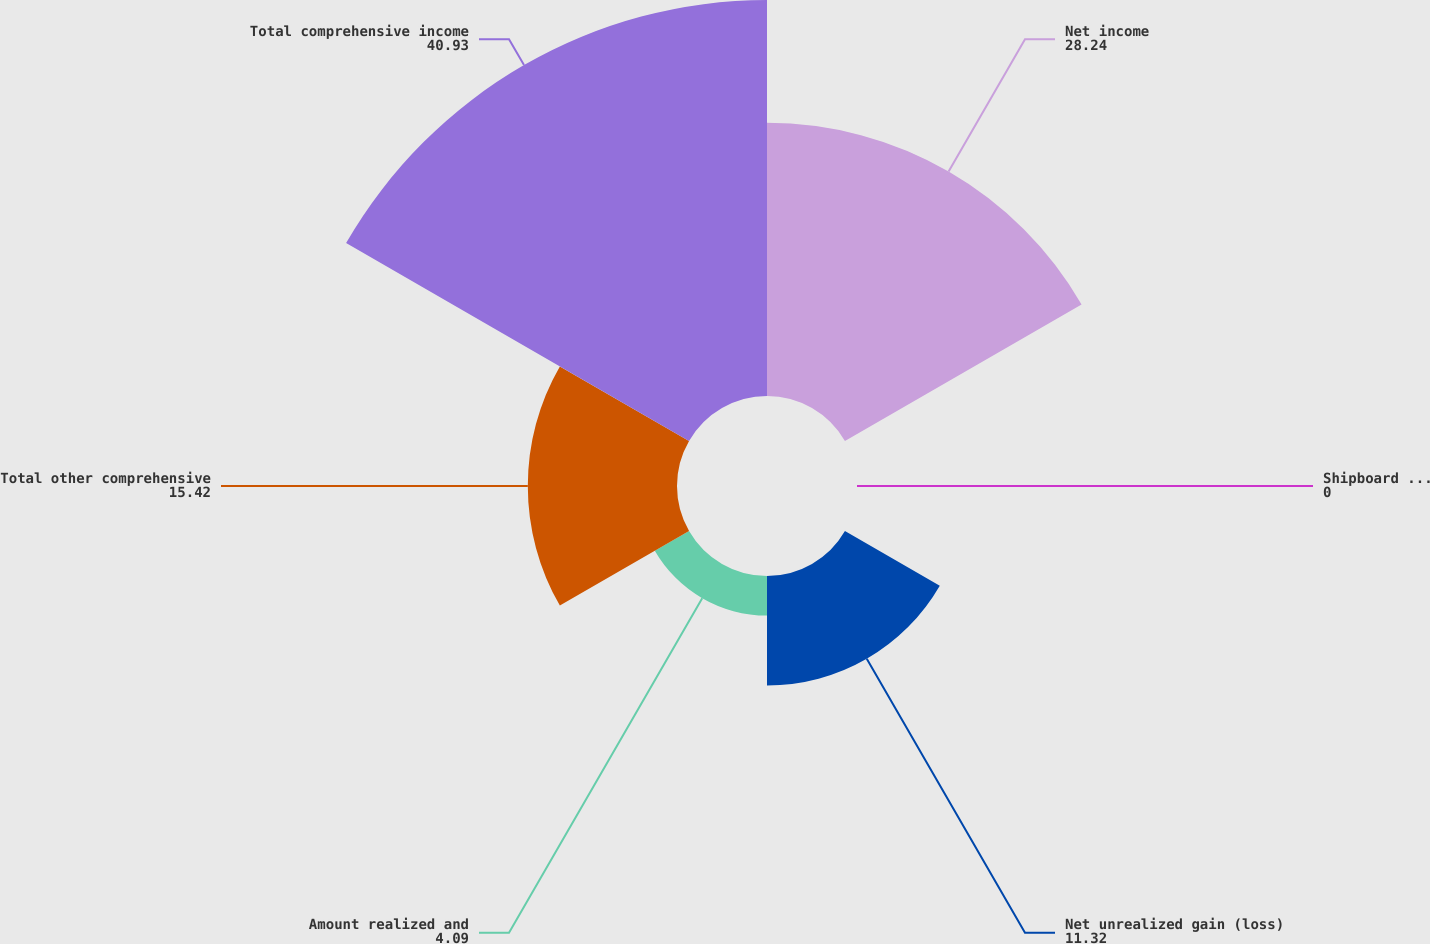<chart> <loc_0><loc_0><loc_500><loc_500><pie_chart><fcel>Net income<fcel>Shipboard Retirement Plan<fcel>Net unrealized gain (loss)<fcel>Amount realized and<fcel>Total other comprehensive<fcel>Total comprehensive income<nl><fcel>28.24%<fcel>0.0%<fcel>11.32%<fcel>4.09%<fcel>15.42%<fcel>40.93%<nl></chart> 